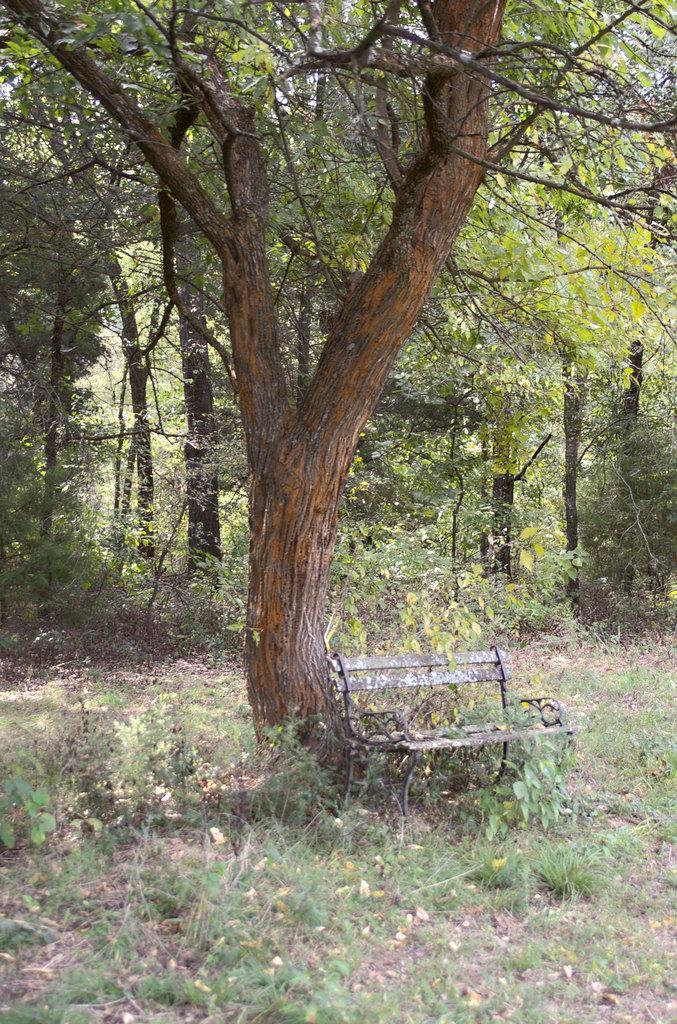Please provide a concise description of this image. In this image in the front there is grass on the ground and in the center there is an empty bench and there is a tree. In the background there are trees and plants. 